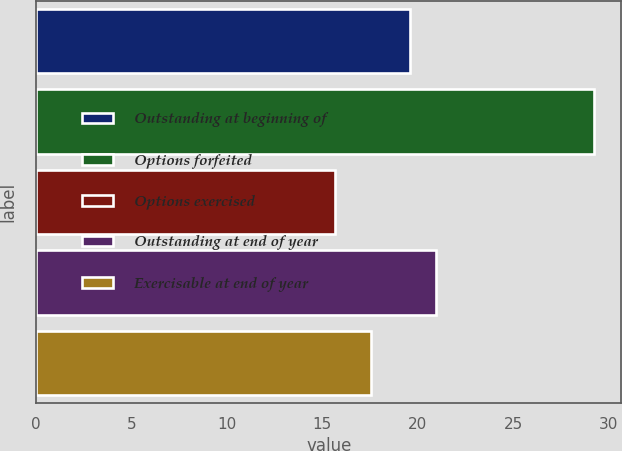Convert chart. <chart><loc_0><loc_0><loc_500><loc_500><bar_chart><fcel>Outstanding at beginning of<fcel>Options forfeited<fcel>Options exercised<fcel>Outstanding at end of year<fcel>Exercisable at end of year<nl><fcel>19.6<fcel>29.22<fcel>15.68<fcel>20.95<fcel>17.56<nl></chart> 